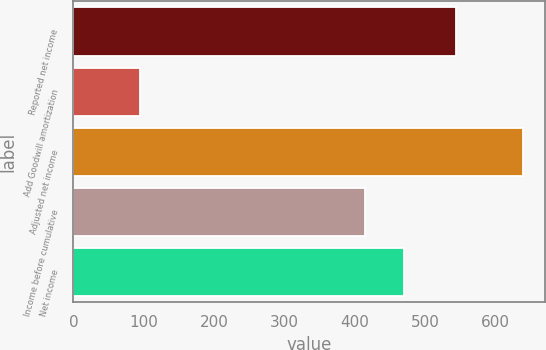Convert chart to OTSL. <chart><loc_0><loc_0><loc_500><loc_500><bar_chart><fcel>Reported net income<fcel>Add Goodwill amortization<fcel>Adjusted net income<fcel>Income before cumulative<fcel>Net income<nl><fcel>544<fcel>95<fcel>639<fcel>415<fcel>469.4<nl></chart> 